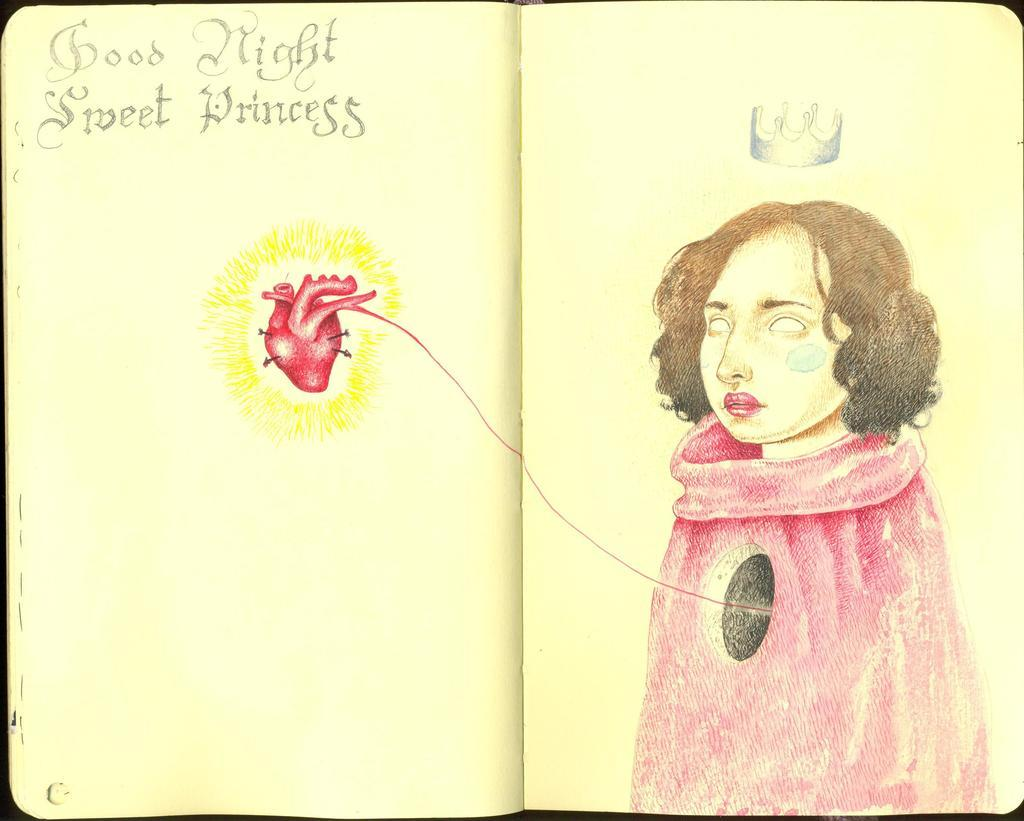What is the main object in the image? There is an open book in the image. What type of content can be found in the book? The book contains text and images. Can you describe the images in the book? The images depict a woman, a crown, and a heart. What type of stage can be seen in the image? There is no stage present in the image; it features an open book with text and images. How does the woman depicted in the images start her day? The image does not provide information about the woman's daily routine or how she starts her day. 